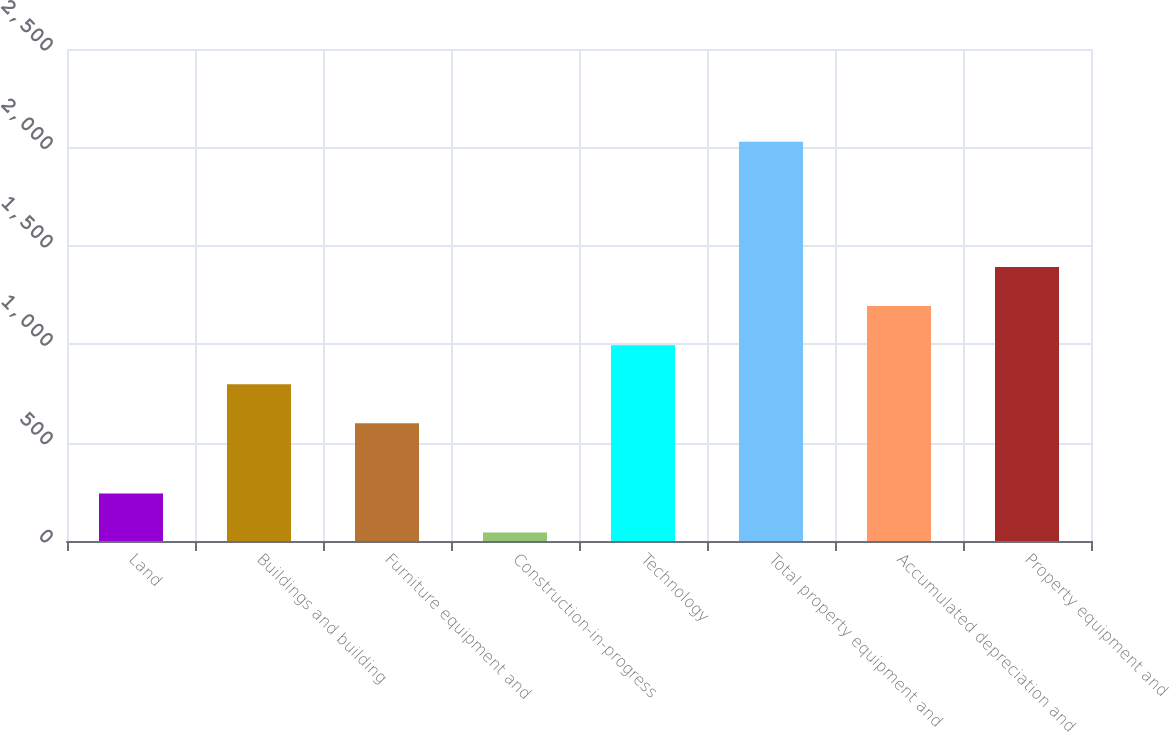Convert chart. <chart><loc_0><loc_0><loc_500><loc_500><bar_chart><fcel>Land<fcel>Buildings and building<fcel>Furniture equipment and<fcel>Construction-in-progress<fcel>Technology<fcel>Total property equipment and<fcel>Accumulated depreciation and<fcel>Property equipment and<nl><fcel>241.6<fcel>796.6<fcel>598<fcel>43<fcel>995.2<fcel>2029<fcel>1193.8<fcel>1392.4<nl></chart> 